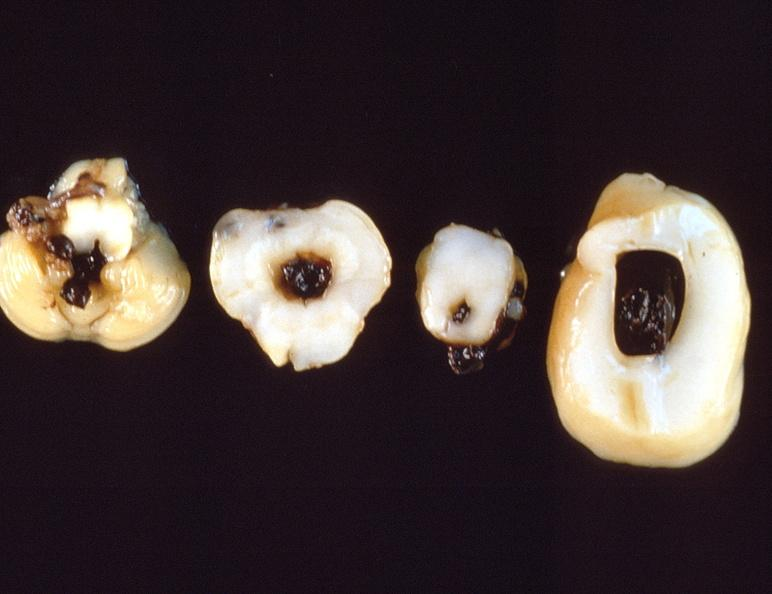does this image show intraventricular hemorrhage, neonate brain?
Answer the question using a single word or phrase. Yes 